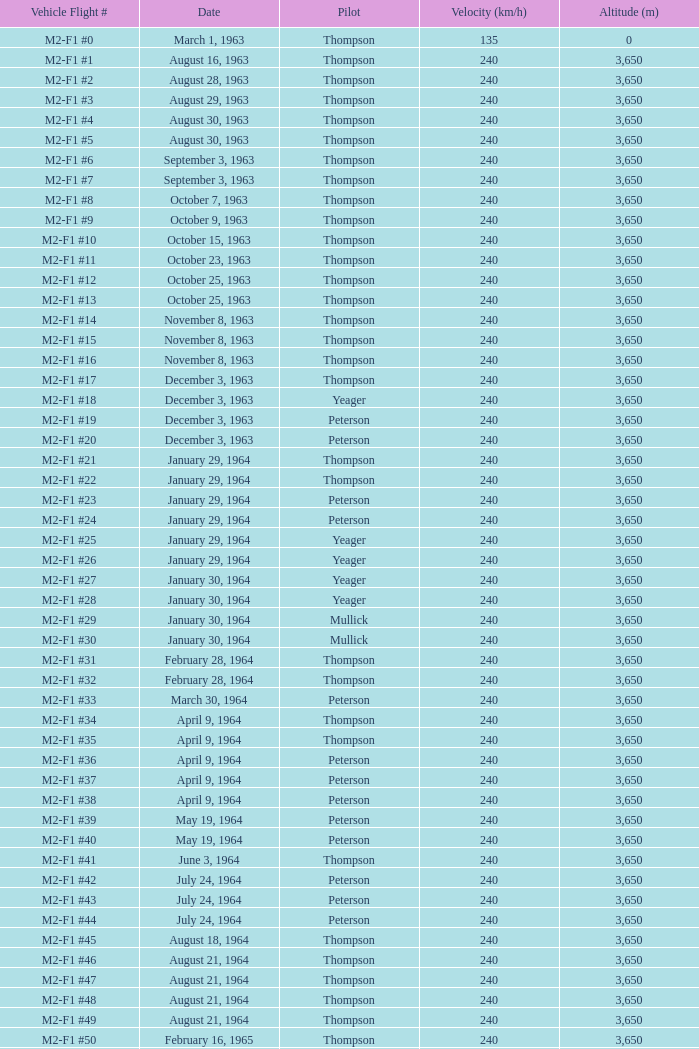On august 16, 1963, what is the velocity? 240.0. Parse the table in full. {'header': ['Vehicle Flight #', 'Date', 'Pilot', 'Velocity (km/h)', 'Altitude (m)'], 'rows': [['M2-F1 #0', 'March 1, 1963', 'Thompson', '135', '0'], ['M2-F1 #1', 'August 16, 1963', 'Thompson', '240', '3,650'], ['M2-F1 #2', 'August 28, 1963', 'Thompson', '240', '3,650'], ['M2-F1 #3', 'August 29, 1963', 'Thompson', '240', '3,650'], ['M2-F1 #4', 'August 30, 1963', 'Thompson', '240', '3,650'], ['M2-F1 #5', 'August 30, 1963', 'Thompson', '240', '3,650'], ['M2-F1 #6', 'September 3, 1963', 'Thompson', '240', '3,650'], ['M2-F1 #7', 'September 3, 1963', 'Thompson', '240', '3,650'], ['M2-F1 #8', 'October 7, 1963', 'Thompson', '240', '3,650'], ['M2-F1 #9', 'October 9, 1963', 'Thompson', '240', '3,650'], ['M2-F1 #10', 'October 15, 1963', 'Thompson', '240', '3,650'], ['M2-F1 #11', 'October 23, 1963', 'Thompson', '240', '3,650'], ['M2-F1 #12', 'October 25, 1963', 'Thompson', '240', '3,650'], ['M2-F1 #13', 'October 25, 1963', 'Thompson', '240', '3,650'], ['M2-F1 #14', 'November 8, 1963', 'Thompson', '240', '3,650'], ['M2-F1 #15', 'November 8, 1963', 'Thompson', '240', '3,650'], ['M2-F1 #16', 'November 8, 1963', 'Thompson', '240', '3,650'], ['M2-F1 #17', 'December 3, 1963', 'Thompson', '240', '3,650'], ['M2-F1 #18', 'December 3, 1963', 'Yeager', '240', '3,650'], ['M2-F1 #19', 'December 3, 1963', 'Peterson', '240', '3,650'], ['M2-F1 #20', 'December 3, 1963', 'Peterson', '240', '3,650'], ['M2-F1 #21', 'January 29, 1964', 'Thompson', '240', '3,650'], ['M2-F1 #22', 'January 29, 1964', 'Thompson', '240', '3,650'], ['M2-F1 #23', 'January 29, 1964', 'Peterson', '240', '3,650'], ['M2-F1 #24', 'January 29, 1964', 'Peterson', '240', '3,650'], ['M2-F1 #25', 'January 29, 1964', 'Yeager', '240', '3,650'], ['M2-F1 #26', 'January 29, 1964', 'Yeager', '240', '3,650'], ['M2-F1 #27', 'January 30, 1964', 'Yeager', '240', '3,650'], ['M2-F1 #28', 'January 30, 1964', 'Yeager', '240', '3,650'], ['M2-F1 #29', 'January 30, 1964', 'Mullick', '240', '3,650'], ['M2-F1 #30', 'January 30, 1964', 'Mullick', '240', '3,650'], ['M2-F1 #31', 'February 28, 1964', 'Thompson', '240', '3,650'], ['M2-F1 #32', 'February 28, 1964', 'Thompson', '240', '3,650'], ['M2-F1 #33', 'March 30, 1964', 'Peterson', '240', '3,650'], ['M2-F1 #34', 'April 9, 1964', 'Thompson', '240', '3,650'], ['M2-F1 #35', 'April 9, 1964', 'Thompson', '240', '3,650'], ['M2-F1 #36', 'April 9, 1964', 'Peterson', '240', '3,650'], ['M2-F1 #37', 'April 9, 1964', 'Peterson', '240', '3,650'], ['M2-F1 #38', 'April 9, 1964', 'Peterson', '240', '3,650'], ['M2-F1 #39', 'May 19, 1964', 'Peterson', '240', '3,650'], ['M2-F1 #40', 'May 19, 1964', 'Peterson', '240', '3,650'], ['M2-F1 #41', 'June 3, 1964', 'Thompson', '240', '3,650'], ['M2-F1 #42', 'July 24, 1964', 'Peterson', '240', '3,650'], ['M2-F1 #43', 'July 24, 1964', 'Peterson', '240', '3,650'], ['M2-F1 #44', 'July 24, 1964', 'Peterson', '240', '3,650'], ['M2-F1 #45', 'August 18, 1964', 'Thompson', '240', '3,650'], ['M2-F1 #46', 'August 21, 1964', 'Thompson', '240', '3,650'], ['M2-F1 #47', 'August 21, 1964', 'Thompson', '240', '3,650'], ['M2-F1 #48', 'August 21, 1964', 'Thompson', '240', '3,650'], ['M2-F1 #49', 'August 21, 1964', 'Thompson', '240', '3,650'], ['M2-F1 #50', 'February 16, 1965', 'Thompson', '240', '3,650'], ['M2-F1 #51', 'May 27, 1965', 'Thompson', '240', '3,650'], ['M2-F1 #52', 'May 27, 1965', 'Thompson', '240', '3,650'], ['M2-F1 #53', 'May 27, 1965', 'Thompson', '240', '3,650'], ['M2-F1 #54', 'May 27, 1965', 'Thompson', '240', '3,650'], ['M2-F1 #55', 'May 27, 1965', 'Sorlie', '240', '3,650'], ['M2-F1 #56', 'May 27, 1965', 'Sorlie', '240', '3,650'], ['M2-F1 #57', 'May 27, 1965', 'Sorlie', '240', '3,650'], ['M2-F1 #58', 'May 28, 1965', 'Thompson', '240', '3,650'], ['M2-F1 #59', 'May 28, 1965', 'Sorlie', '240', '3,650'], ['M2-F1 #60', 'May 28, 1965', 'Sorlie', '240', '3,650'], ['M2-F1 #61', 'July 16, 1965', 'Thompson', '240', '3,650'], ['M2-F1 #62', 'July 16, 1965', 'Dana', '240', '3,650'], ['M2-F1 #63', 'July 16, 1965', 'Gentry', '200', '10'], ['M2-F1 #64', 'August 30, 1965', 'Thompson', '240', '3,650'], ['M2-F1 #65', 'August 30, 1965', 'Thompson', '240', '3,650'], ['M2-F1 #66', 'August 30, 1965', 'Thompson', '240', '3,650'], ['M2-F1 #67', 'August 31, 1965', 'Thompson', '240', '3,650'], ['M2-F1 #68', 'October 6, 1965', 'Thompson', '240', '3,650'], ['M2-F1 #69', 'October 6, 1965', 'Thompson', '240', '3,650'], ['M2-F1 #70', 'October 8, 1965', 'Thompson', '240', '3,650'], ['M2-F1 #71', 'March 28, 1966', 'Thompson', '240', '3,650'], ['M2-F1 #72', 'March 28, 1966', 'Thompson', '240', '3,650'], ['M2-F1 #73', 'August 4, 1966', 'Peterson', '240', '3,650'], ['M2-F1 #74', 'August 5, 1966', 'Peterson', '240', '3,650'], ['M2-F1 #75', 'August 5, 1966', 'Peterson', '240', '3,650'], ['M2-F1 #76', 'August 5, 1966', 'Peterson', '240', '3,650'], ['M2-F1 #77', 'August 16, 1966', 'Gentry', '200', '10']]} 